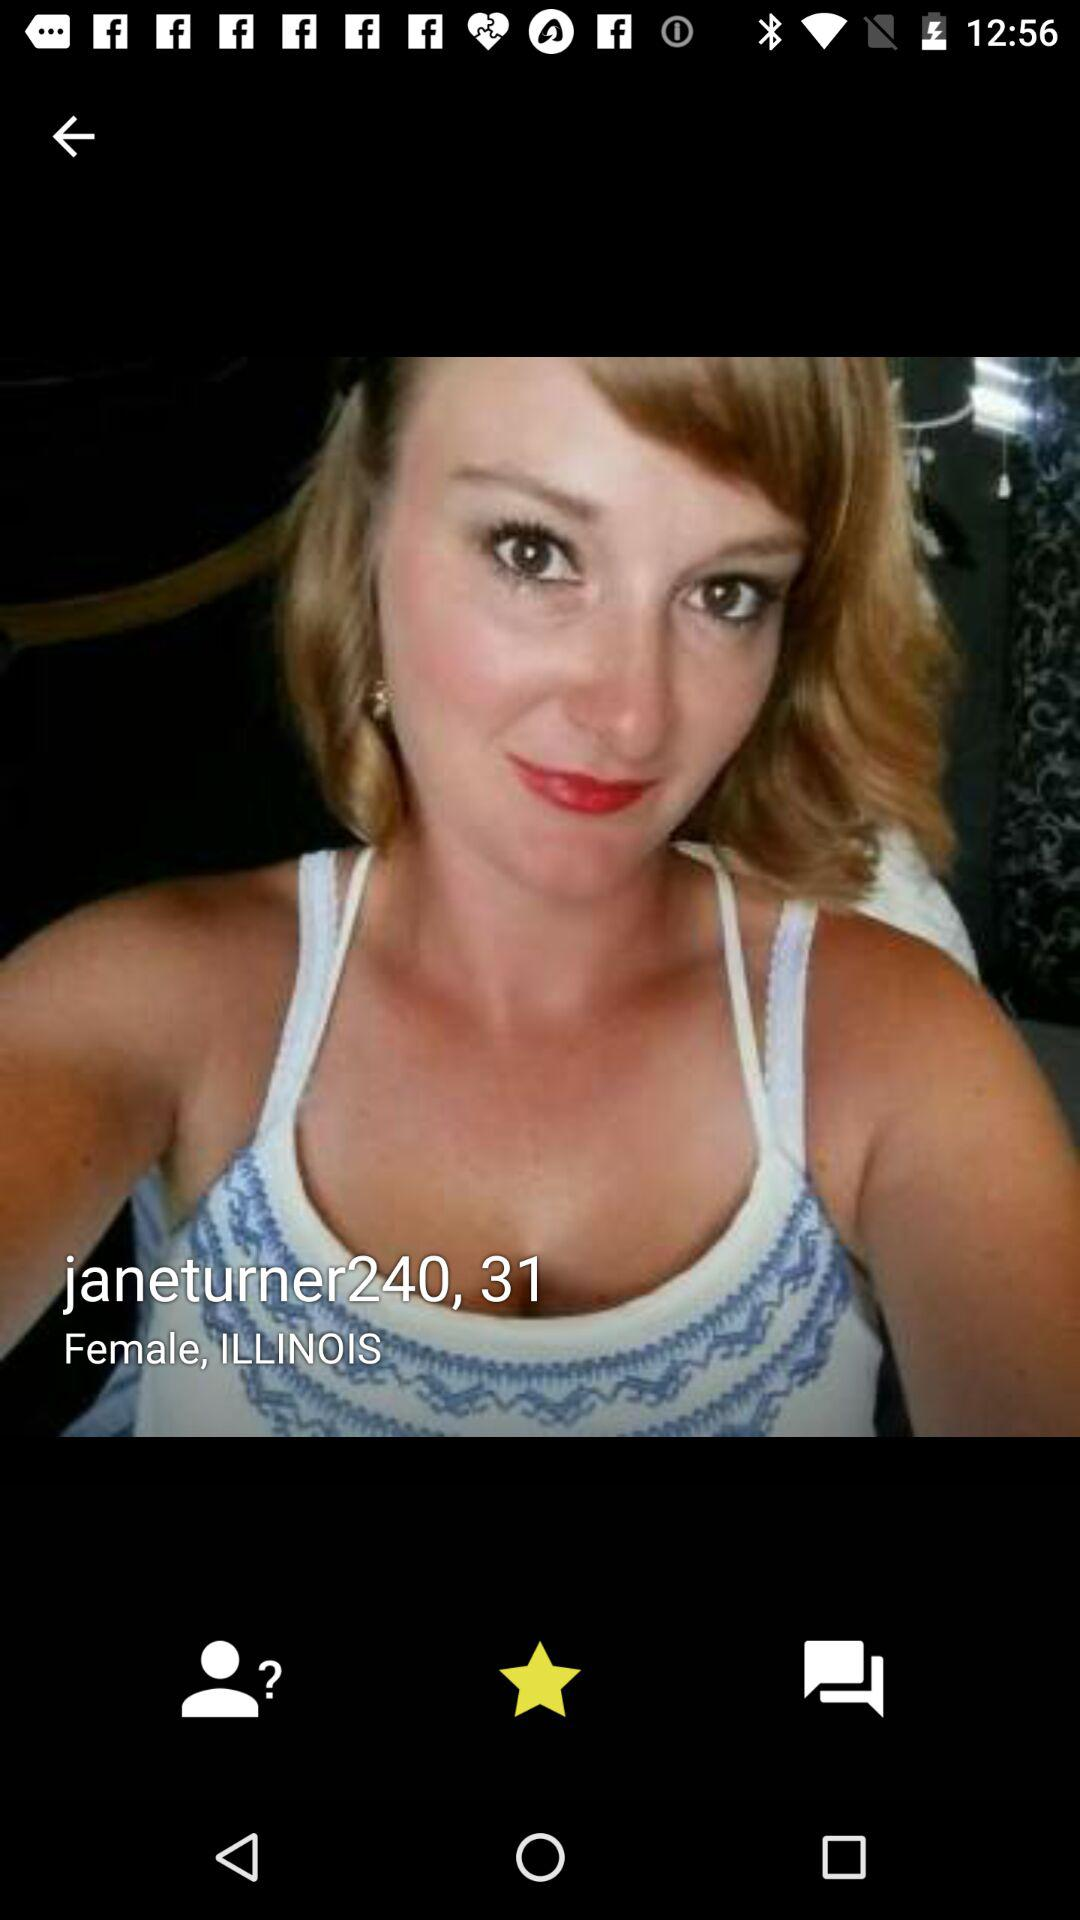What is the age? The age is 31. 